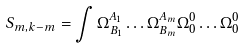Convert formula to latex. <formula><loc_0><loc_0><loc_500><loc_500>S _ { m , k - m } = \int \Omega _ { B _ { 1 } } ^ { A _ { 1 } } \dots \Omega _ { B _ { m } } ^ { A _ { m } } \Omega _ { 0 } ^ { 0 } \dots \Omega _ { 0 } ^ { 0 }</formula> 